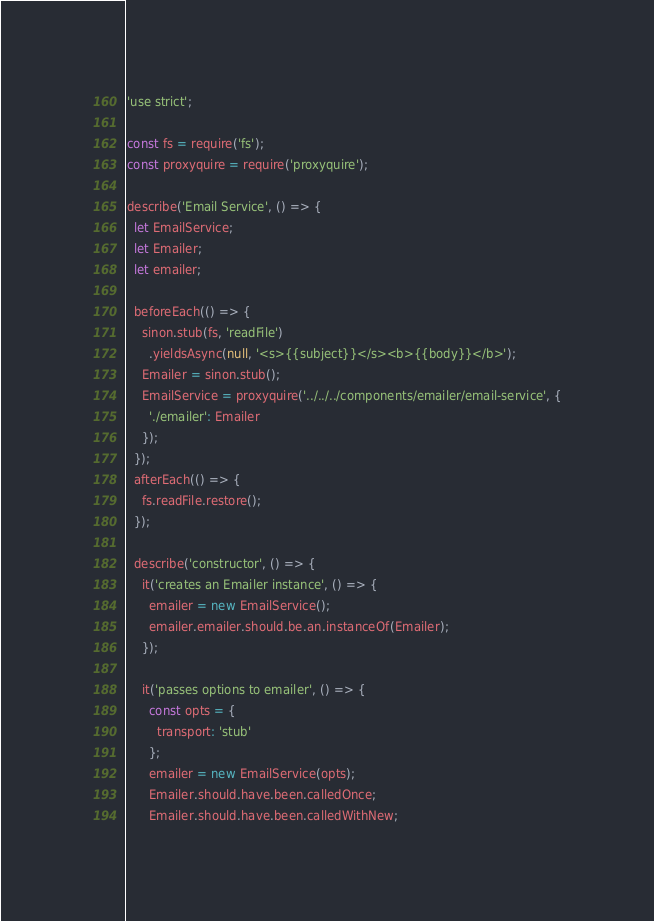<code> <loc_0><loc_0><loc_500><loc_500><_JavaScript_>'use strict';

const fs = require('fs');
const proxyquire = require('proxyquire');

describe('Email Service', () => {
  let EmailService;
  let Emailer;
  let emailer;

  beforeEach(() => {
    sinon.stub(fs, 'readFile')
      .yieldsAsync(null, '<s>{{subject}}</s><b>{{body}}</b>');
    Emailer = sinon.stub();
    EmailService = proxyquire('../../../components/emailer/email-service', {
      './emailer': Emailer
    });
  });
  afterEach(() => {
    fs.readFile.restore();
  });

  describe('constructor', () => {
    it('creates an Emailer instance', () => {
      emailer = new EmailService();
      emailer.emailer.should.be.an.instanceOf(Emailer);
    });

    it('passes options to emailer', () => {
      const opts = {
        transport: 'stub'
      };
      emailer = new EmailService(opts);
      Emailer.should.have.been.calledOnce;
      Emailer.should.have.been.calledWithNew;</code> 